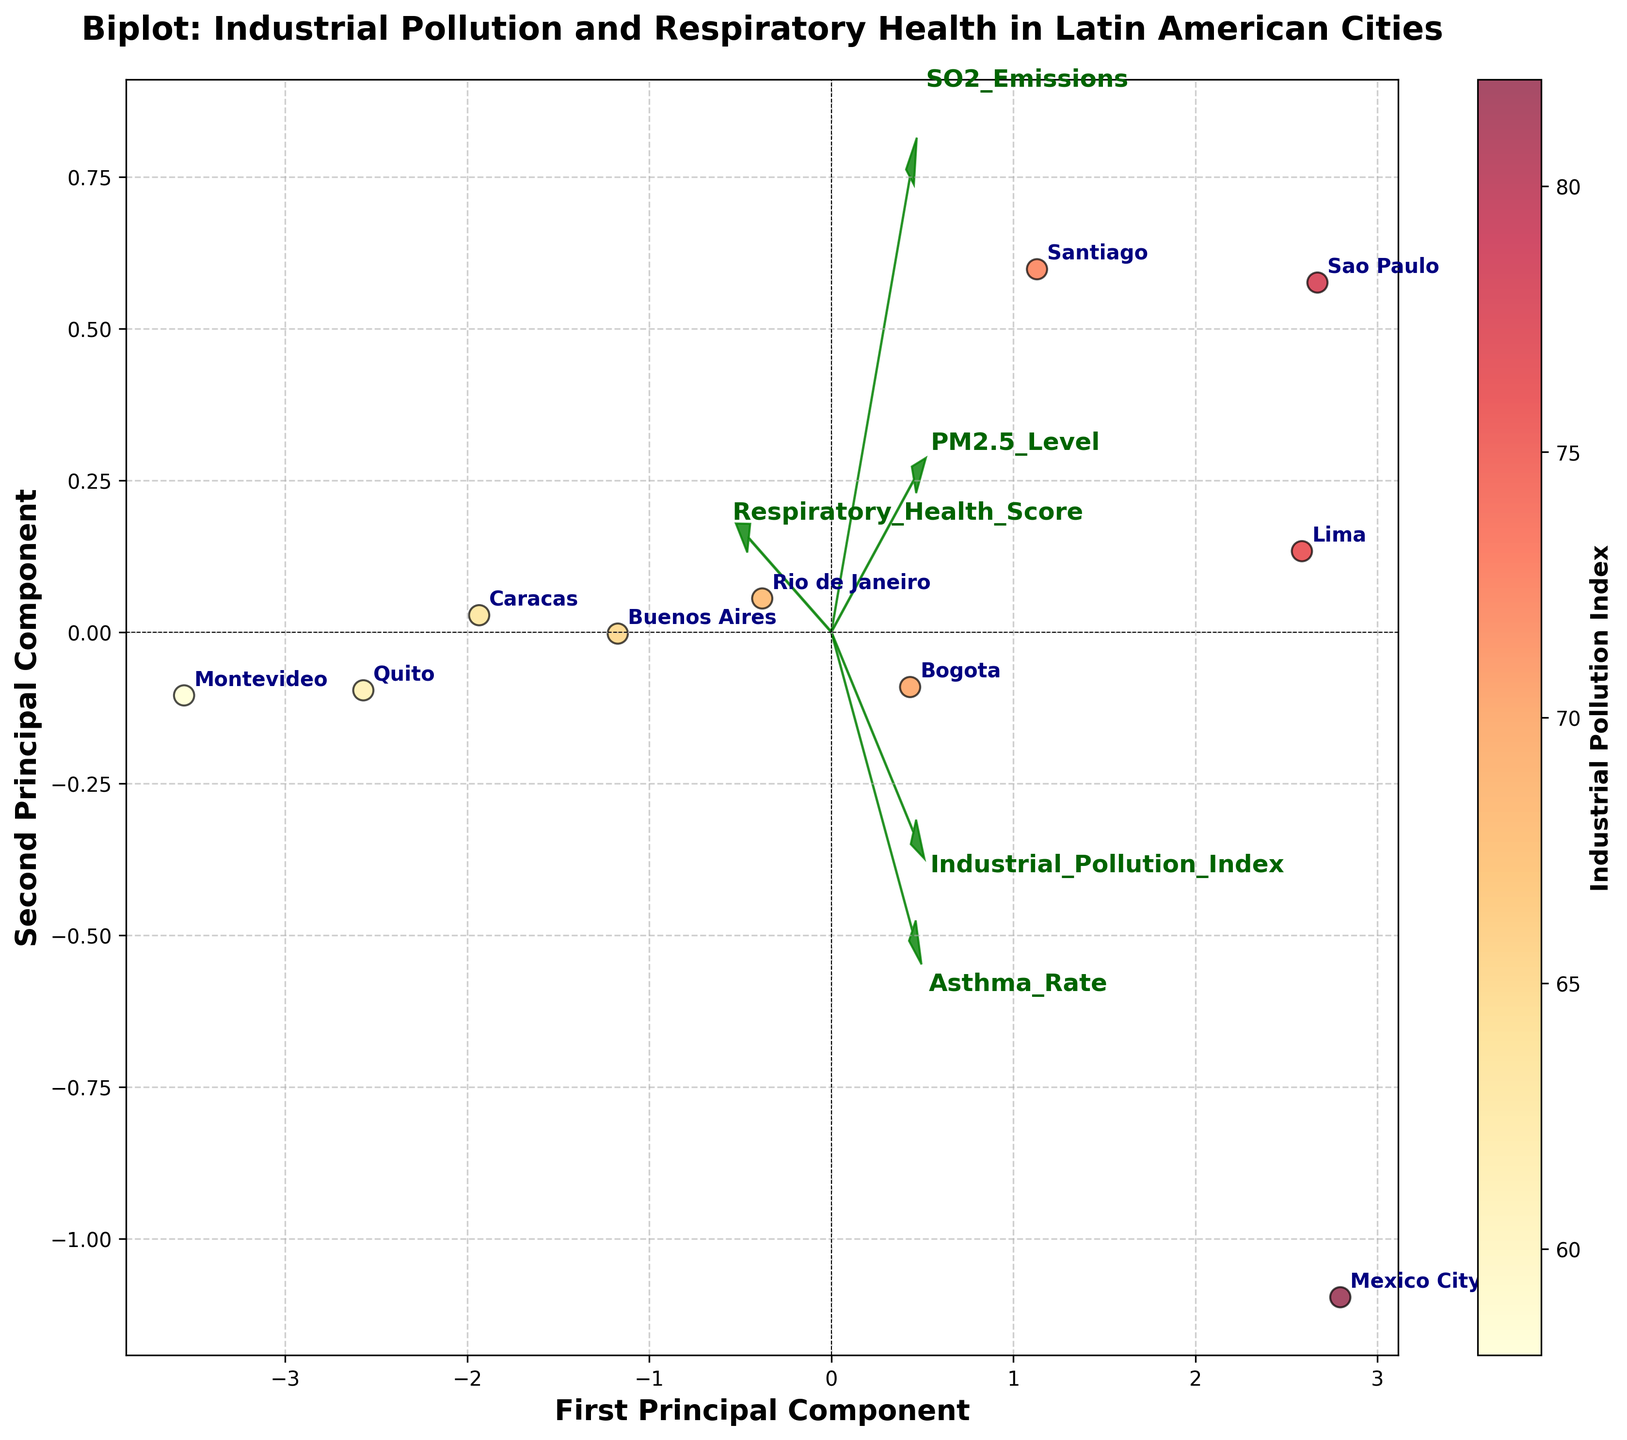which city has the highest industrial pollution index? The scatter plot color represents the Industrial Pollution Index, and the highest color intensity is linked with the highest index. Observing the color shades in the plot, the city with the darkest color is Mexico City.
Answer: Mexico City how many cities are plotted on the biplot? The biplot has labeled data points for each city. There are 10 distinct labels for cities visible on the plot.
Answer: 10 which city has the highest respiratory health score? By observing the position and labels in the scatter plot, the city positioned furthest in the direction of the Respiratory Health Score vector arrow is Montevideo.
Answer: Montevideo how does the industrial pollution index relate to the first principal component? The direction of the Industrial Pollution Index vector is aligned with the first principal component, indicating that cities with a high Industrial Pollution Index typically have a higher value of the first principal component.
Answer: Positively correlated is there any city positioned close to the origin? The origin (0,0) is at the center of the biplot. Observing the scatter points, Rio de Janeiro and Buenos Aires are relatively close to the origin.
Answer: Rio de Janeiro and Buenos Aires between sao paulo and lima, which city has a higher asthma rate? Referring to the general positioning along the Asthma Rate vector, Lima is positioned in a direction indicating a higher asthma rate compared to Sao Paulo.
Answer: Lima which feature has the longest vector and what does this imply? By observing the lengths of the vectors, PM2.5_Level has the longest vector. This implies that PM2.5_Level has a strong relationship with the principal components and greatly influences the data separation along these components.
Answer: PM2.5_Level; strong influence what does the color scale represent in the biplot? The color of the scatter points varies with intensity, corresponding to the Industrial Pollution Index.
Answer: Industrial Pollution Index 